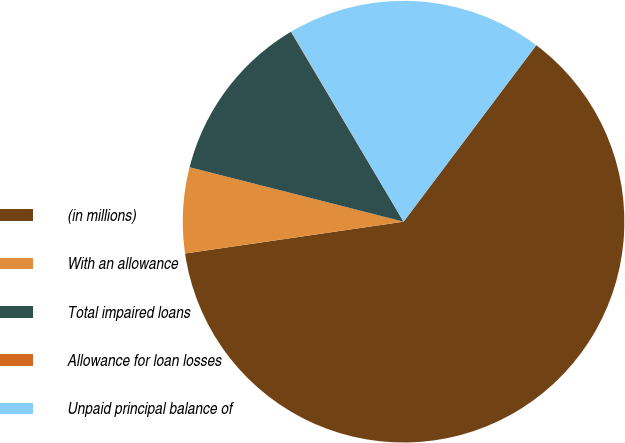Convert chart to OTSL. <chart><loc_0><loc_0><loc_500><loc_500><pie_chart><fcel>(in millions)<fcel>With an allowance<fcel>Total impaired loans<fcel>Allowance for loan losses<fcel>Unpaid principal balance of<nl><fcel>62.43%<fcel>6.27%<fcel>12.51%<fcel>0.03%<fcel>18.75%<nl></chart> 